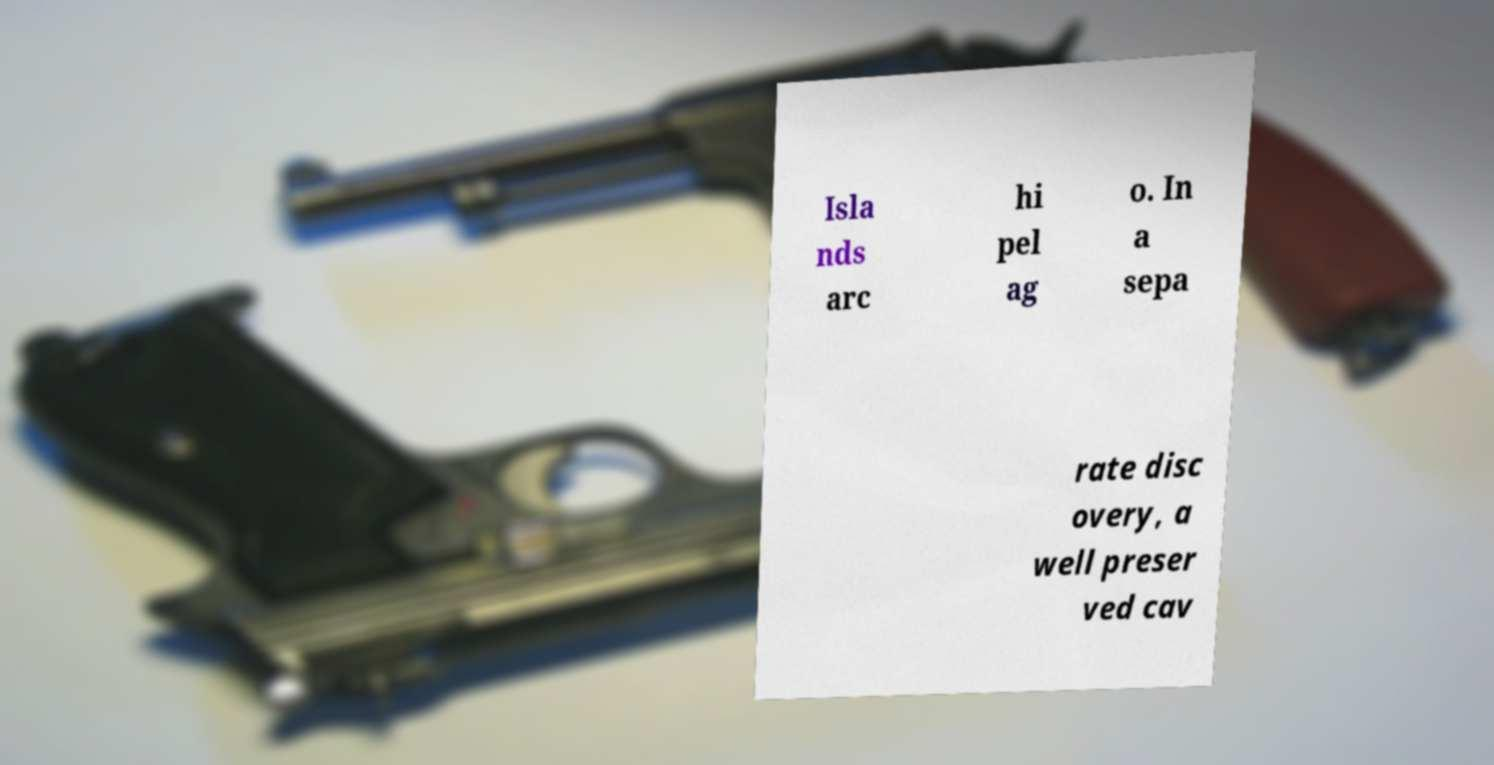Can you read and provide the text displayed in the image?This photo seems to have some interesting text. Can you extract and type it out for me? Isla nds arc hi pel ag o. In a sepa rate disc overy, a well preser ved cav 